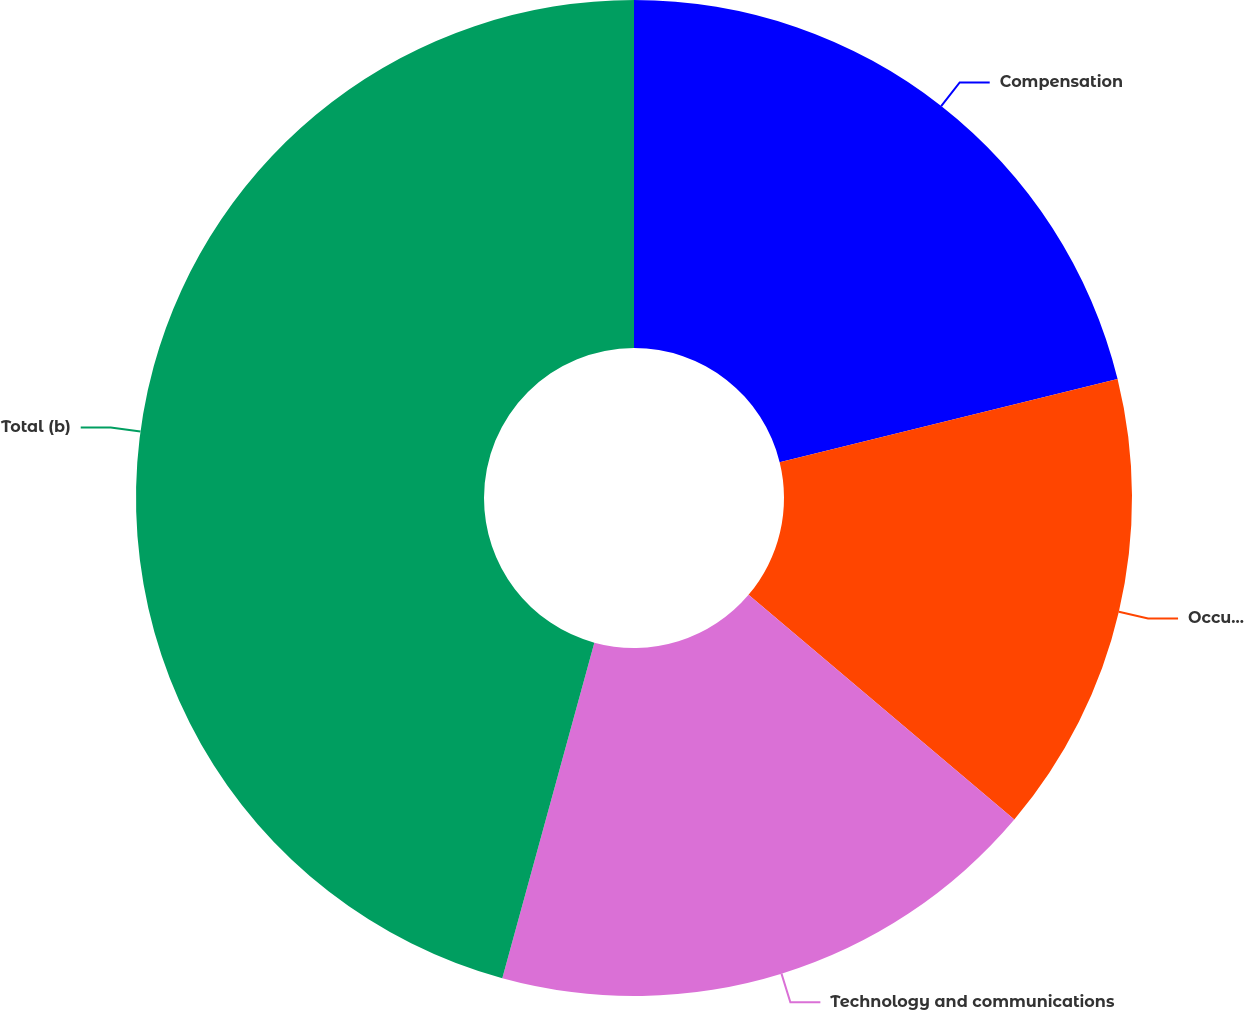<chart> <loc_0><loc_0><loc_500><loc_500><pie_chart><fcel>Compensation<fcel>Occupancy<fcel>Technology and communications<fcel>Total (b)<nl><fcel>21.16%<fcel>15.01%<fcel>18.09%<fcel>45.74%<nl></chart> 